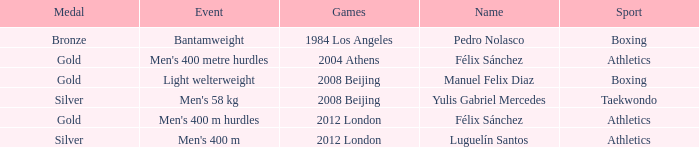Which Name had a Games of 2008 beijing, and a Medal of gold? Manuel Felix Diaz. 